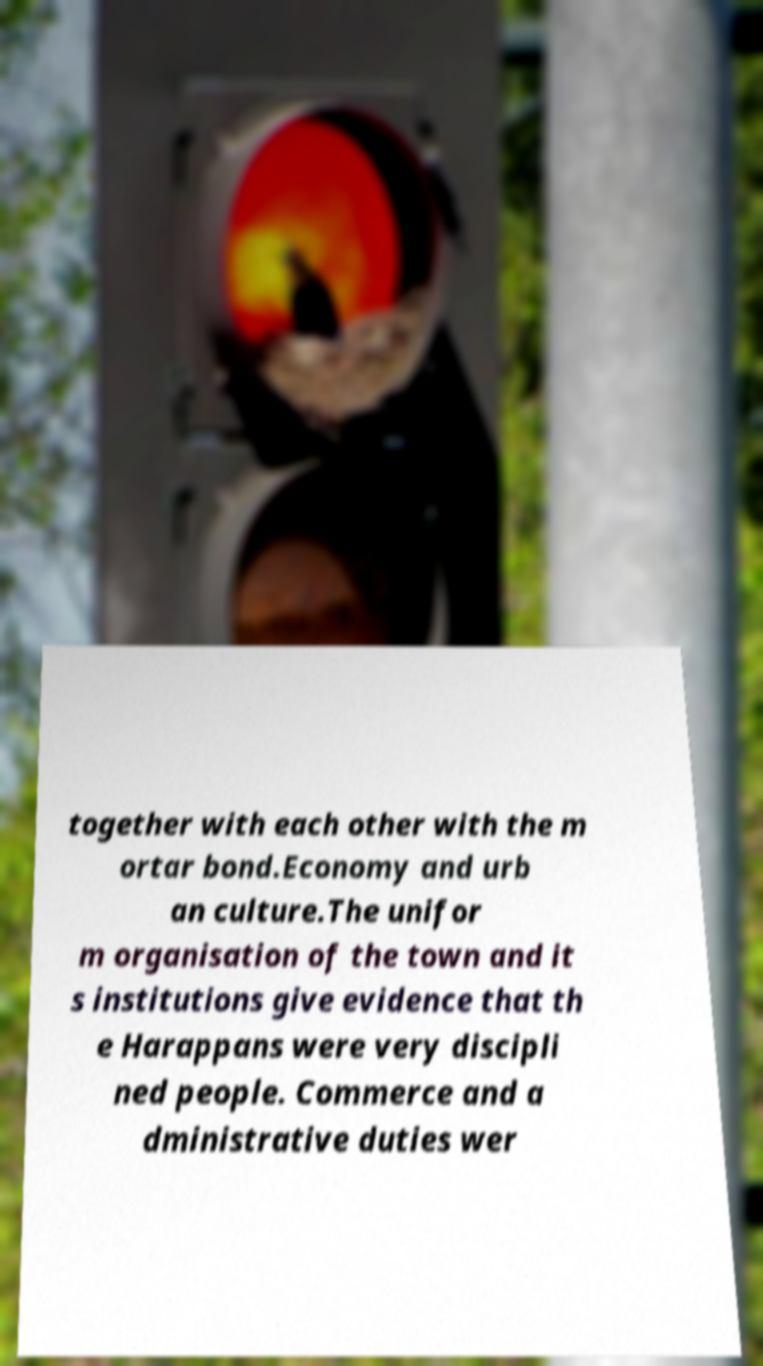Can you read and provide the text displayed in the image?This photo seems to have some interesting text. Can you extract and type it out for me? together with each other with the m ortar bond.Economy and urb an culture.The unifor m organisation of the town and it s institutions give evidence that th e Harappans were very discipli ned people. Commerce and a dministrative duties wer 